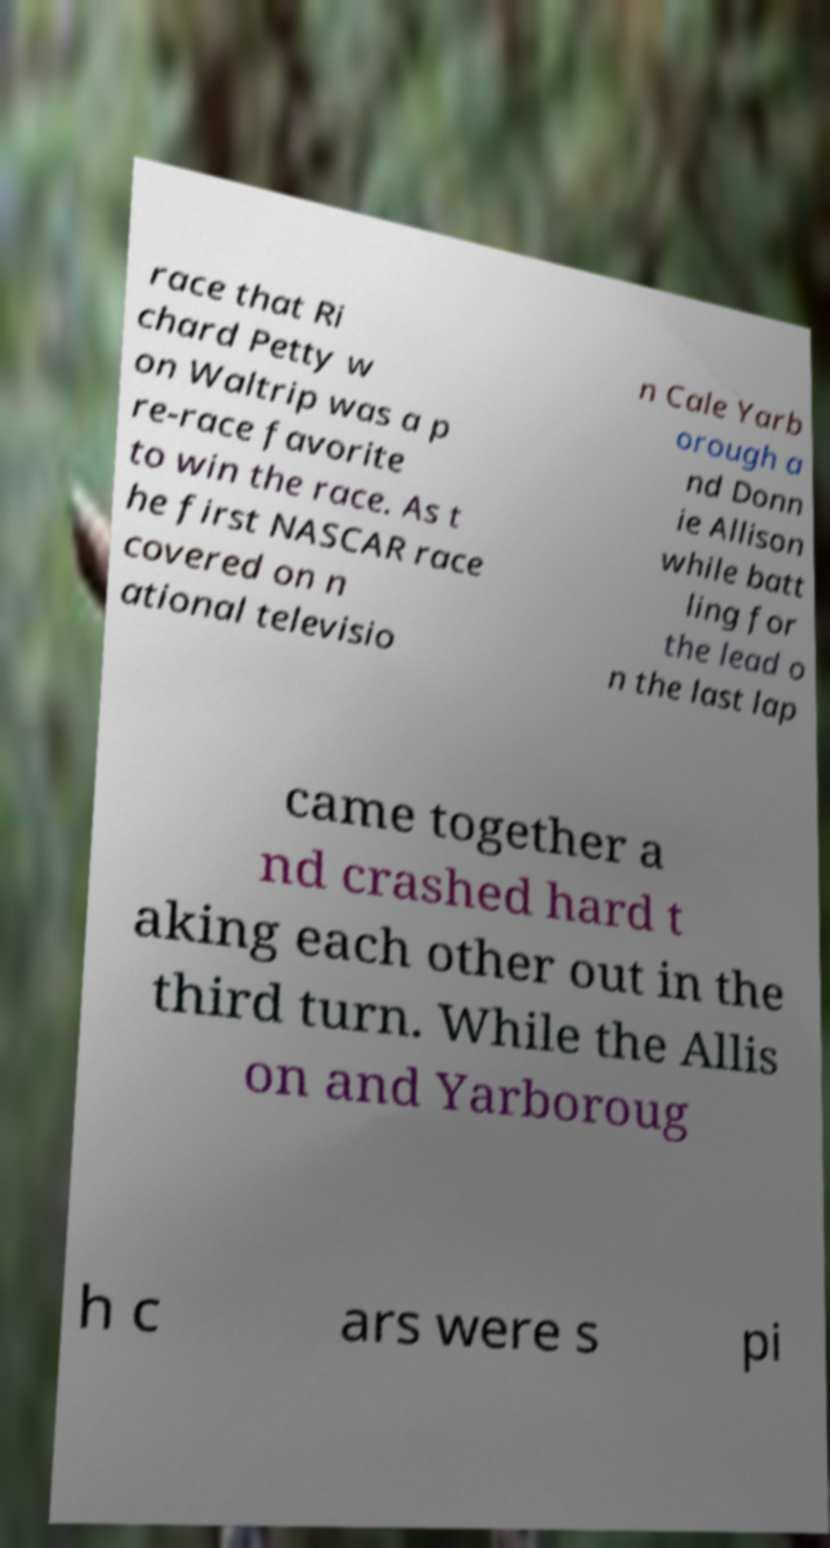Could you extract and type out the text from this image? race that Ri chard Petty w on Waltrip was a p re-race favorite to win the race. As t he first NASCAR race covered on n ational televisio n Cale Yarb orough a nd Donn ie Allison while batt ling for the lead o n the last lap came together a nd crashed hard t aking each other out in the third turn. While the Allis on and Yarboroug h c ars were s pi 